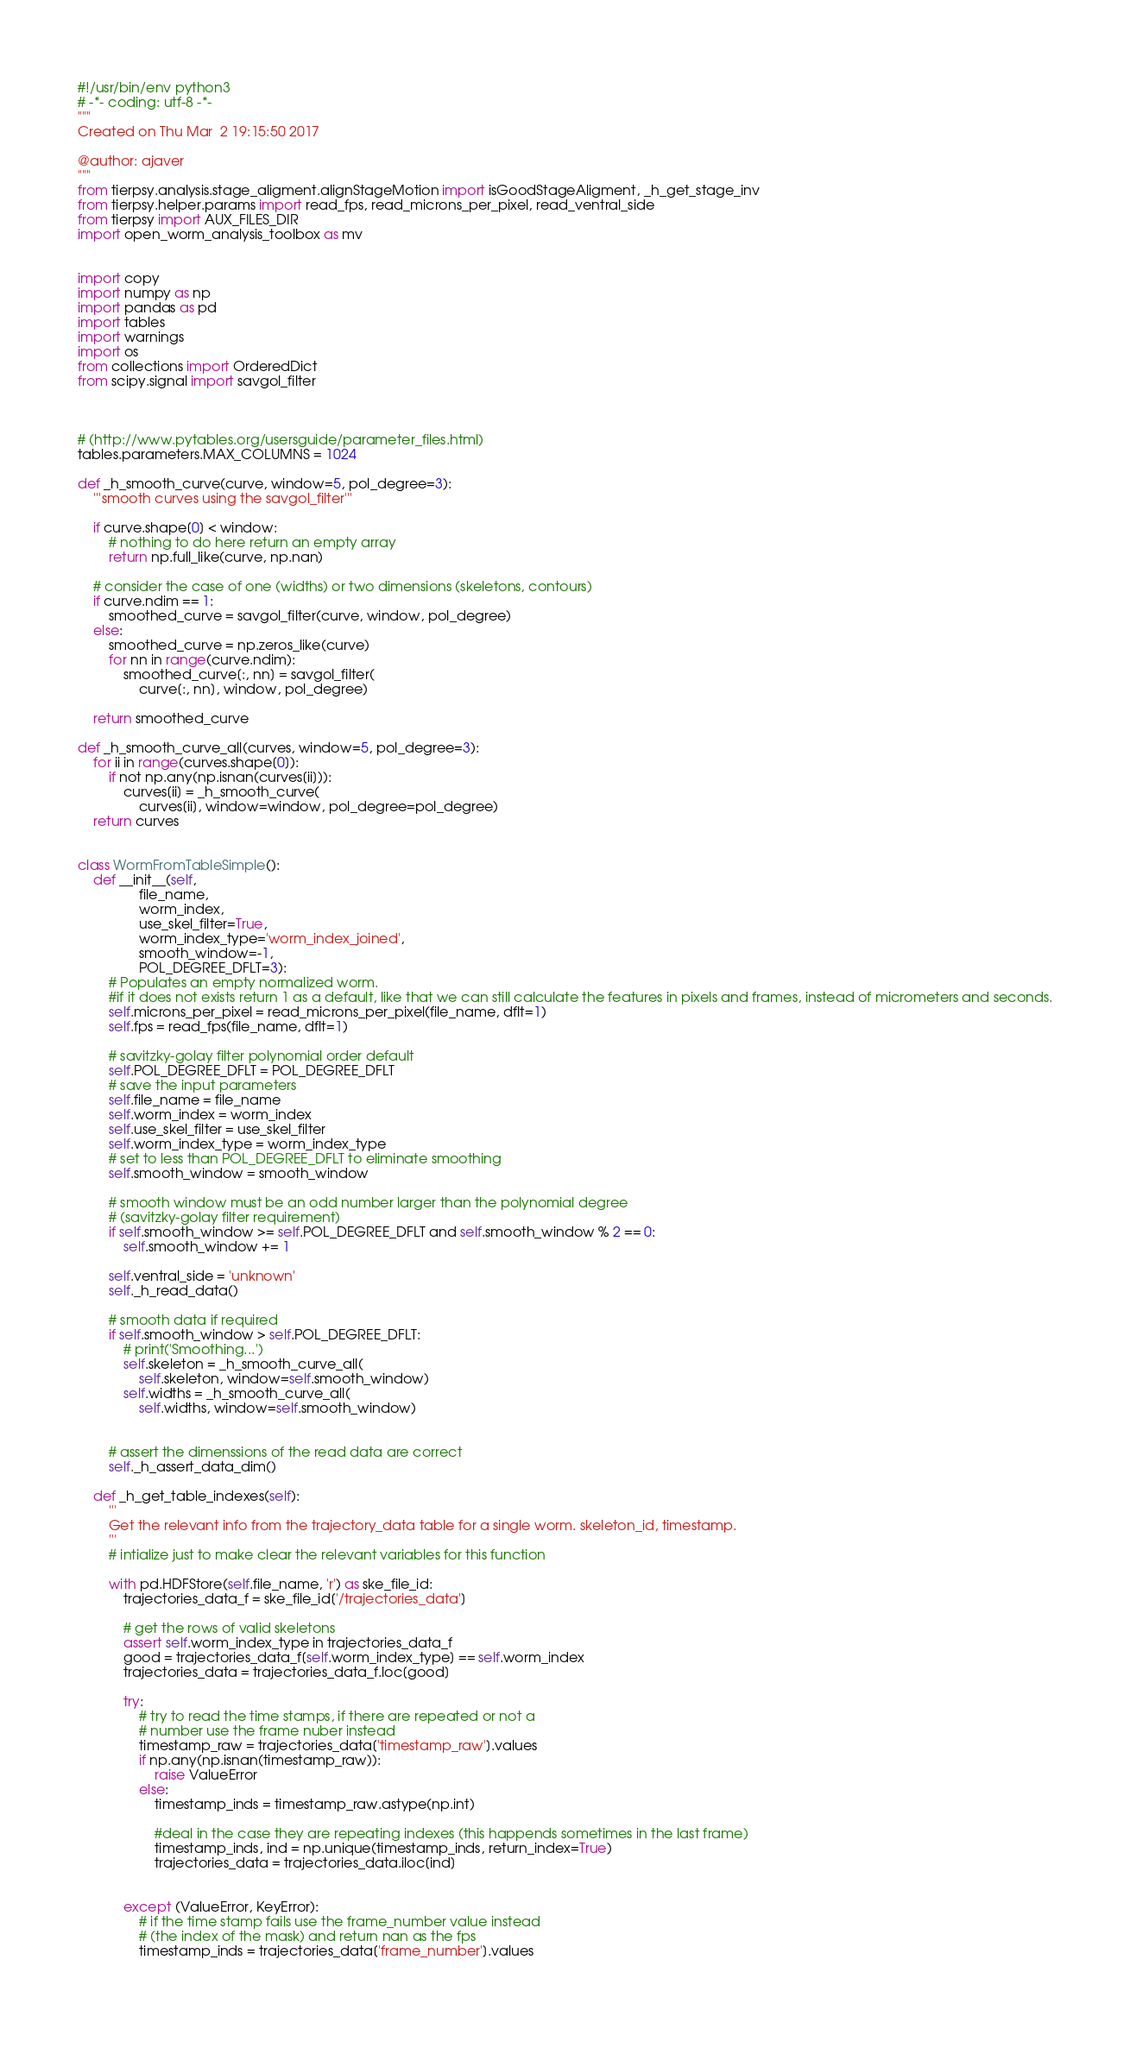<code> <loc_0><loc_0><loc_500><loc_500><_Python_>#!/usr/bin/env python3
# -*- coding: utf-8 -*-
"""
Created on Thu Mar  2 19:15:50 2017

@author: ajaver
"""
from tierpsy.analysis.stage_aligment.alignStageMotion import isGoodStageAligment, _h_get_stage_inv
from tierpsy.helper.params import read_fps, read_microns_per_pixel, read_ventral_side
from tierpsy import AUX_FILES_DIR
import open_worm_analysis_toolbox as mv


import copy
import numpy as np
import pandas as pd
import tables
import warnings
import os
from collections import OrderedDict
from scipy.signal import savgol_filter



# (http://www.pytables.org/usersguide/parameter_files.html)
tables.parameters.MAX_COLUMNS = 1024

def _h_smooth_curve(curve, window=5, pol_degree=3):
    '''smooth curves using the savgol_filter'''

    if curve.shape[0] < window:
        # nothing to do here return an empty array
        return np.full_like(curve, np.nan)

    # consider the case of one (widths) or two dimensions (skeletons, contours)
    if curve.ndim == 1:
        smoothed_curve = savgol_filter(curve, window, pol_degree)
    else:
        smoothed_curve = np.zeros_like(curve)
        for nn in range(curve.ndim):
            smoothed_curve[:, nn] = savgol_filter(
                curve[:, nn], window, pol_degree)

    return smoothed_curve

def _h_smooth_curve_all(curves, window=5, pol_degree=3):
    for ii in range(curves.shape[0]):
        if not np.any(np.isnan(curves[ii])):
            curves[ii] = _h_smooth_curve(
                curves[ii], window=window, pol_degree=pol_degree)
    return curves


class WormFromTableSimple():
    def __init__(self, 
                file_name, 
                worm_index, 
                use_skel_filter=True,
                worm_index_type='worm_index_joined',
                smooth_window=-1, 
                POL_DEGREE_DFLT=3):
        # Populates an empty normalized worm.
        #if it does not exists return 1 as a default, like that we can still calculate the features in pixels and frames, instead of micrometers and seconds.
        self.microns_per_pixel = read_microns_per_pixel(file_name, dflt=1)
        self.fps = read_fps(file_name, dflt=1)
        
        # savitzky-golay filter polynomial order default
        self.POL_DEGREE_DFLT = POL_DEGREE_DFLT
        # save the input parameters
        self.file_name = file_name
        self.worm_index = worm_index
        self.use_skel_filter = use_skel_filter
        self.worm_index_type = worm_index_type
        # set to less than POL_DEGREE_DFLT to eliminate smoothing
        self.smooth_window = smooth_window

        # smooth window must be an odd number larger than the polynomial degree
        # (savitzky-golay filter requirement)
        if self.smooth_window >= self.POL_DEGREE_DFLT and self.smooth_window % 2 == 0:
            self.smooth_window += 1

        self.ventral_side = 'unknown'
        self._h_read_data()

        # smooth data if required
        if self.smooth_window > self.POL_DEGREE_DFLT:
            # print('Smoothing...')
            self.skeleton = _h_smooth_curve_all(
                self.skeleton, window=self.smooth_window)
            self.widths = _h_smooth_curve_all(
                self.widths, window=self.smooth_window)

        
        # assert the dimenssions of the read data are correct
        self._h_assert_data_dim()

    def _h_get_table_indexes(self):
        '''
        Get the relevant info from the trajectory_data table for a single worm. skeleton_id, timestamp.
        '''
        # intialize just to make clear the relevant variables for this function

        with pd.HDFStore(self.file_name, 'r') as ske_file_id:
            trajectories_data_f = ske_file_id['/trajectories_data']

            # get the rows of valid skeletons
            assert self.worm_index_type in trajectories_data_f
            good = trajectories_data_f[self.worm_index_type] == self.worm_index
            trajectories_data = trajectories_data_f.loc[good]
                        
            try:
                # try to read the time stamps, if there are repeated or not a
                # number use the frame nuber instead
                timestamp_raw = trajectories_data['timestamp_raw'].values
                if np.any(np.isnan(timestamp_raw)):
                    raise ValueError
                else:
                    timestamp_inds = timestamp_raw.astype(np.int)
                    
                    #deal in the case they are repeating indexes (this happends sometimes in the last frame)
                    timestamp_inds, ind = np.unique(timestamp_inds, return_index=True)
                    trajectories_data = trajectories_data.iloc[ind]
                    

            except (ValueError, KeyError):
                # if the time stamp fails use the frame_number value instead
                # (the index of the mask) and return nan as the fps
                timestamp_inds = trajectories_data['frame_number'].values
            
</code> 